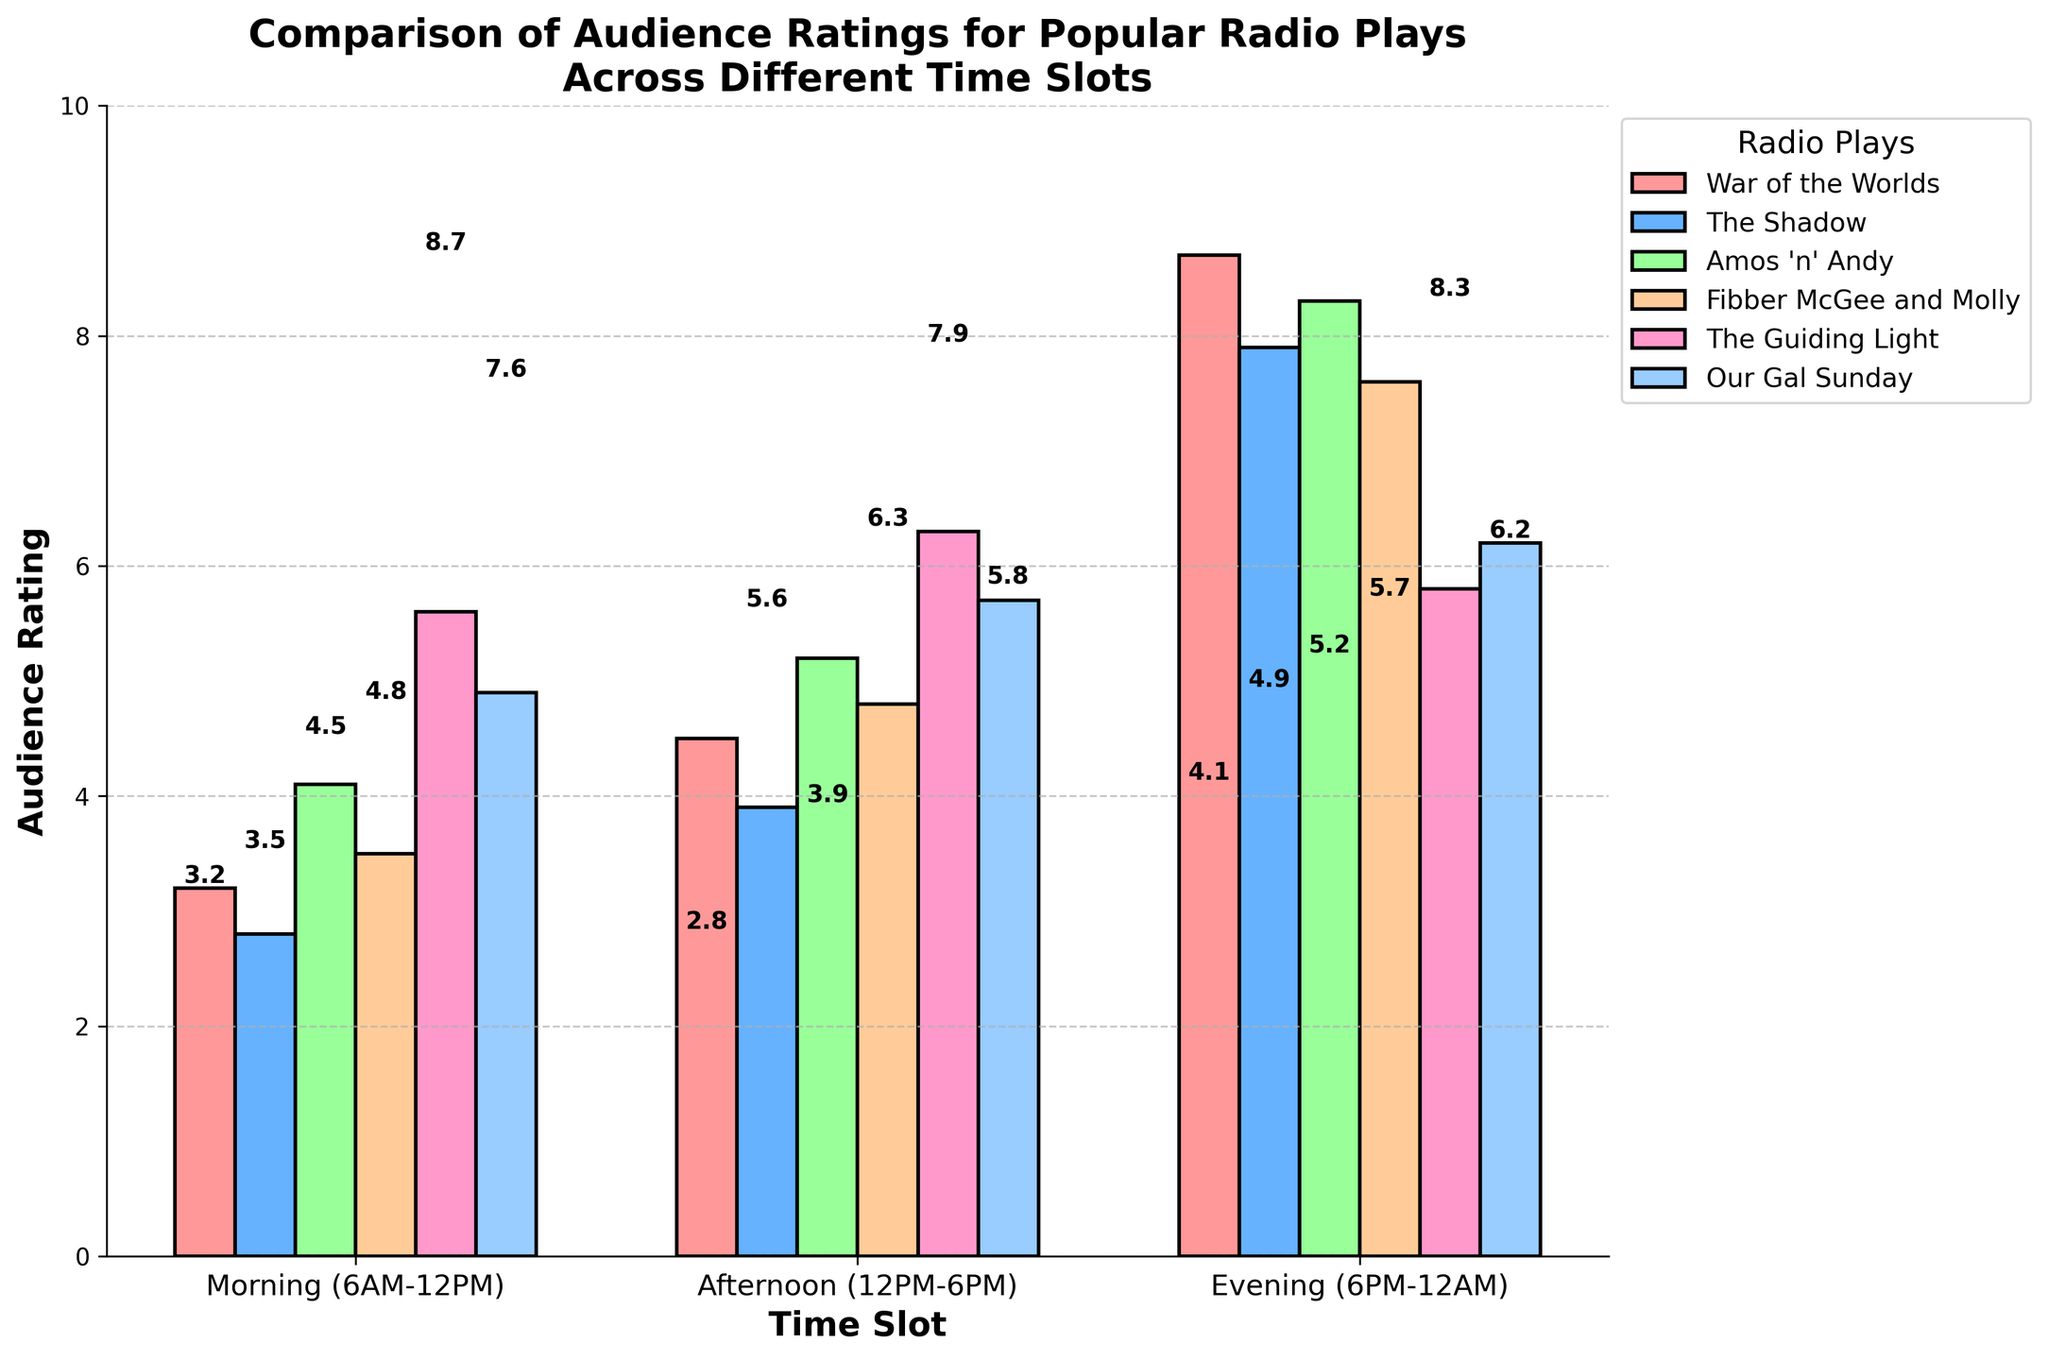What's the average audience rating for "The Shadow" across all time slots? To find the average rating for "The Shadow," add the ratings for "The Shadow" across all time slots (2.8 + 3.9 + 7.9) and divide by the number of time slots (3). So, (2.8 + 3.9 + 7.9) / 3 = 14.6 / 3 = 4.87.
Answer: 4.87 Which radio play has the highest audience rating in the evening time slot? By examining the bars representing the evening time slot, the highest rating is for "War of the Worlds" with a value of 8.7.
Answer: War of the Worlds Compare the sum of "Fibber McGee and Molly"'s ratings in the morning and afternoon time slots to its evening rating. Adding "Fibber McGee and Molly"'s ratings for morning and afternoon (3.5 + 4.8 = 8.3) and comparing it to the evening rating (7.6), the sum of morning and afternoon (8.3) is greater than the evening rating (7.6).
Answer: Morning & Afternoon > Evening By how much does the audience rating of "Amos 'n' Andy" increase from the morning to the evening time slot? Subtract the morning rating of "Amos 'n' Andy" from its evening rating (8.3 - 4.1 = 4.2). The increase in audience rating is 4.2.
Answer: 4.2 Which radio play shows the most significant increase from afternoon to evening ratings? By calculating the differences between afternoon and evening ratings for each play, "The Shadow" has the most significant increase (7.9 - 3.9 = 4.0).
Answer: The Shadow What is the total audience rating for "Our Gal Sunday" across all time slots? Adding up the ratings of "Our Gal Sunday" for all time slots (4.9 + 5.7 + 6.2) gives 16.8.
Answer: 16.8 Is there a time slot where "The Guiding Light" does not have the highest rating among all the plays? In the evening time slot, "The Guiding Light" does not have the highest rating (5.8), as "War of the Worlds" (8.7), "The Shadow" (7.9), "Amos 'n' Andy" (8.3), and "Fibber McGee and Molly" (7.6) have higher ratings.
Answer: Yes What color represents the highest-rated play in the morning slot? The highest-rated play in the morning slot is "The Guiding Light" with a rating of 5.6, which is represented by the pink bar.
Answer: Pink 